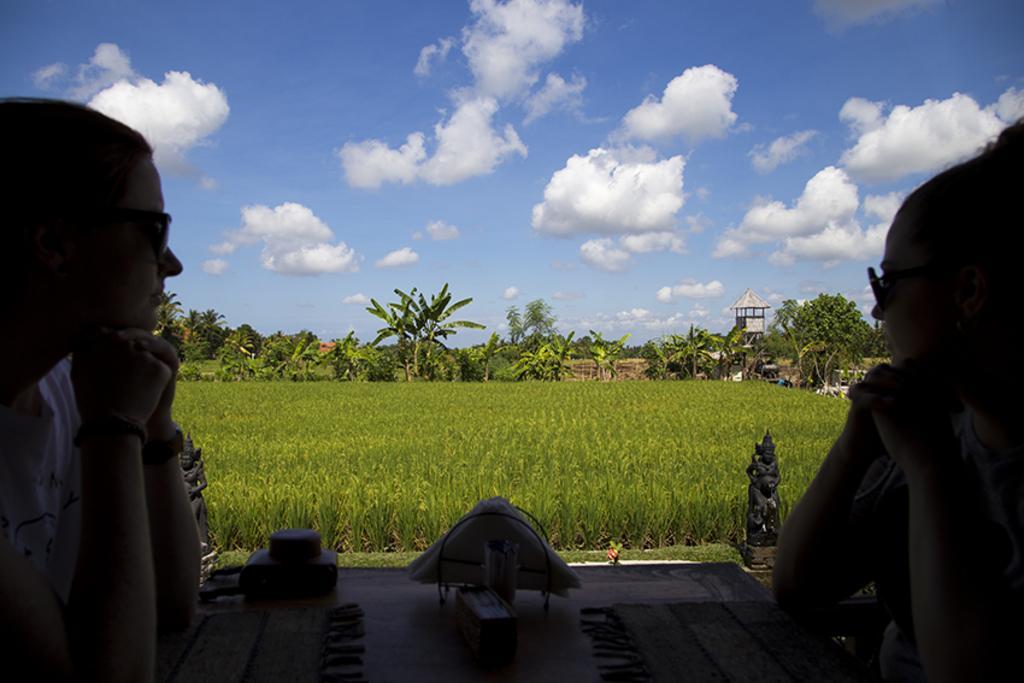Can you describe this image briefly? On the left side, there is a woman wearing sunglasses, sitting, keeping both elbows on a cloth which is on a table, on which there are some objects. On the right side, there is another woman, wearing sunglasses, sitting and keeping both elbows on a cloth which is on the table. In the background, there is a statue, there is a form field, there are trees, there is a shelter and there are clouds in the blue sky. 